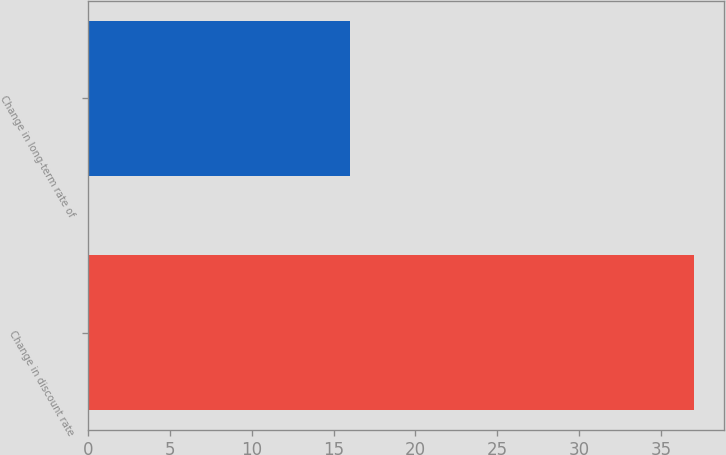Convert chart. <chart><loc_0><loc_0><loc_500><loc_500><bar_chart><fcel>Change in discount rate<fcel>Change in long-term rate of<nl><fcel>37<fcel>16<nl></chart> 